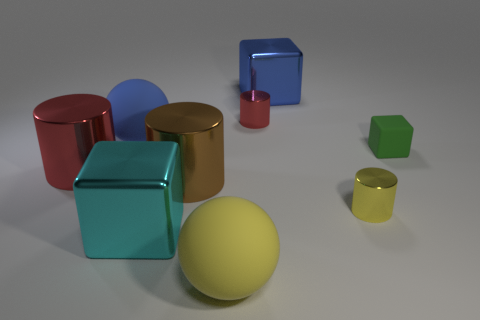Subtract all green balls. How many red cylinders are left? 2 Subtract all small yellow shiny cylinders. How many cylinders are left? 3 Add 1 green rubber things. How many objects exist? 10 Subtract all brown cylinders. How many cylinders are left? 3 Subtract all spheres. How many objects are left? 7 Subtract all purple cubes. Subtract all brown balls. How many cubes are left? 3 Subtract all small metallic things. Subtract all big red cylinders. How many objects are left? 6 Add 7 large blue balls. How many large blue balls are left? 8 Add 9 tiny blocks. How many tiny blocks exist? 10 Subtract 1 yellow spheres. How many objects are left? 8 